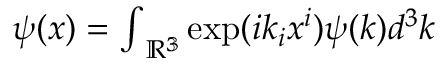Convert formula to latex. <formula><loc_0><loc_0><loc_500><loc_500>\begin{array} { r } { { \psi } ( x ) = { \int } _ { \mathbb { R ^ { 3 } } } \exp ( i { k } _ { i } { x } ^ { i } ) \psi ( k ) d ^ { 3 } k } \end{array}</formula> 